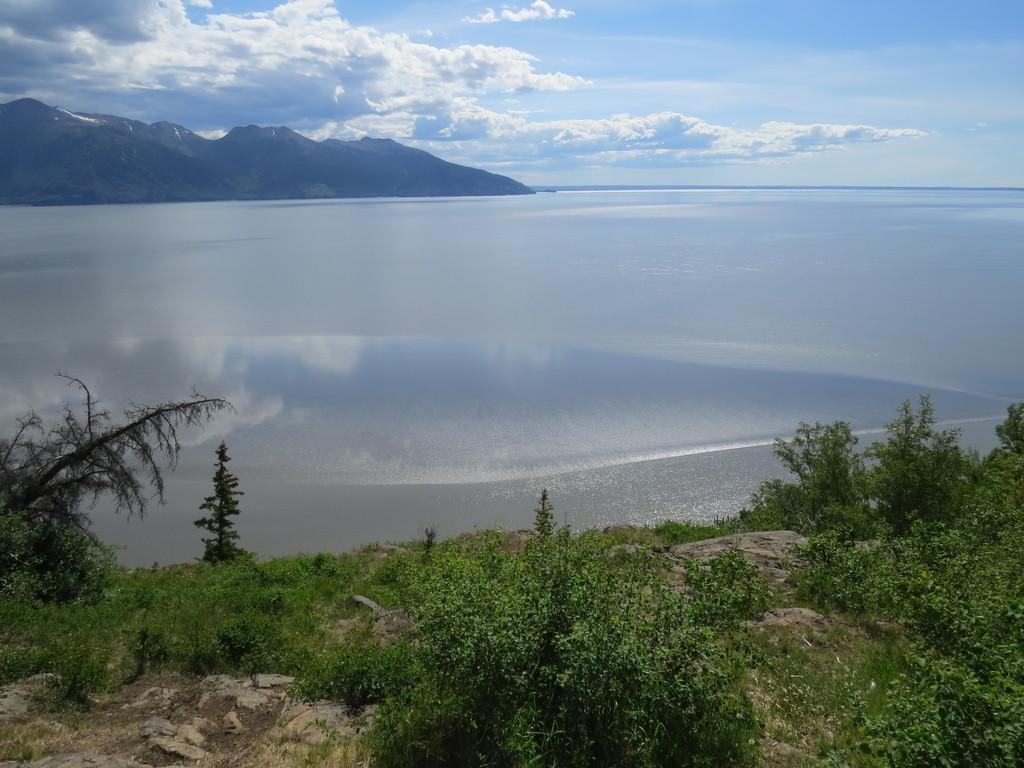What type of vegetation can be seen in the image? There are green plants in the image. What large body of water is visible in the image? There is a sea in the image. What is the primary liquid visible in the image? There is water visible in the image. What type of landform can be seen in the image? There are mountains in the image. What part of the natural environment is visible at the top of the image? The sky is visible at the top of the image. What atmospheric feature can be seen in the sky? Clouds are present in the sky. Can you tell me how many zephyrs are blowing in the image? There is no mention of zephyrs in the image, as it features green plants, a sea, water, mountains, the sky, and clouds. What is the argument about in the image? There is no argument present in the image; it is a natural scene with green plants, a sea, water, mountains, the sky, and clouds. 